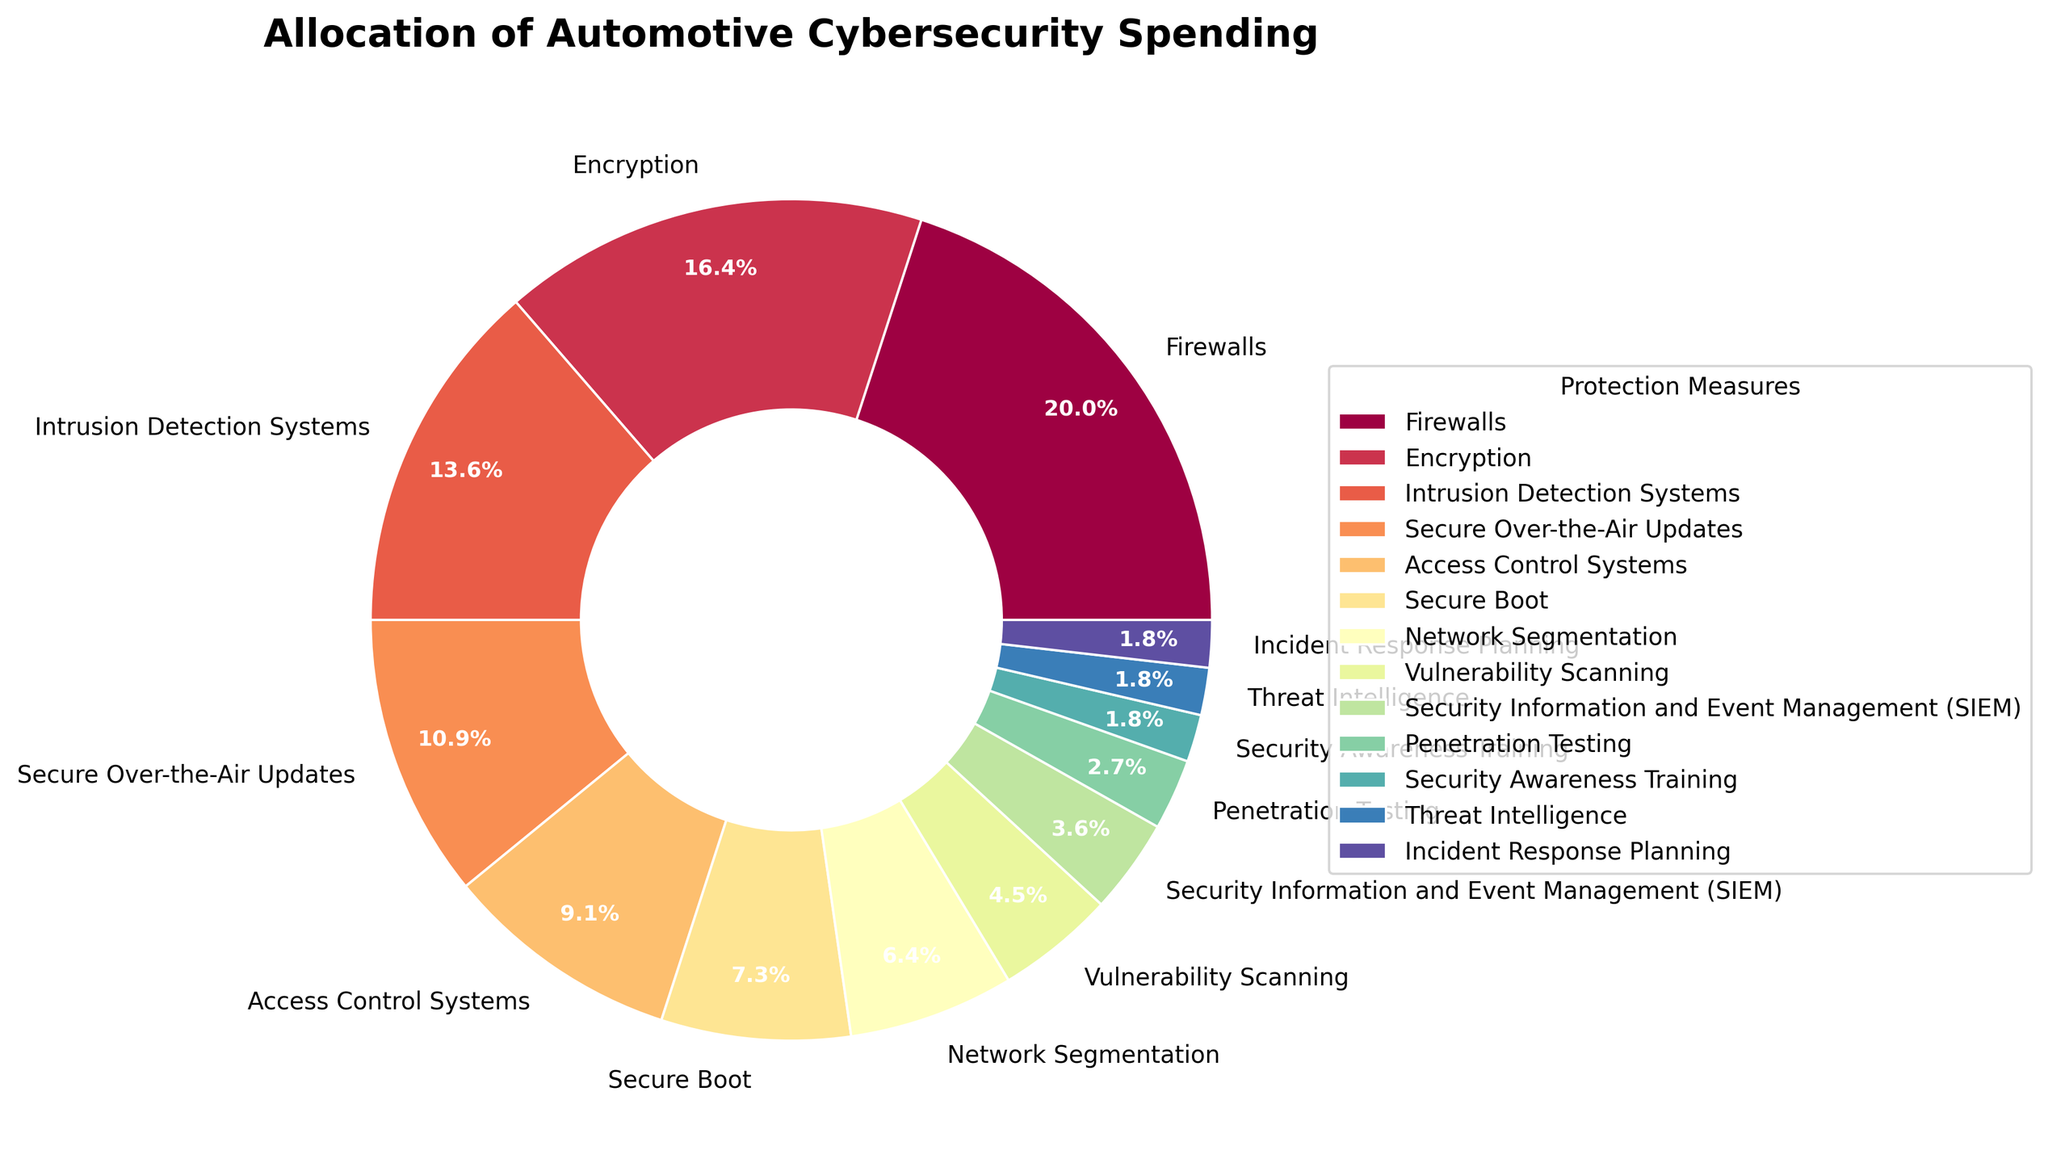How much more is spent on Firewalls compared to Encryption? The percentage allocated to Firewalls is 22%, and for Encryption, it is 18%. The difference can be calculated by subtracting the percentage for Encryption from Firewalls: 22% - 18% = 4%.
Answer: 4% Which two categories have the smallest allocations, and what are their combined percentages? The smallest allocations are Security Awareness Training, Threat Intelligence, and Incident Response Planning, each with 2% of the total spending. The combined percentage is calculated as 2% + 2% + 2% = 6%.
Answer: Security Awareness Training, Threat Intelligence, and Incident Response Planning, 6% What is the total percentage of spending allocated to Secure Boot and Network Segmentation combined? Secure Boot has a percentage of 8%, and Network Segmentation has a percentage of 7%. Adding these together gives 8% + 7% = 15%.
Answer: 15% Which category has the highest allocation, and by how much does it exceed the category with the second-highest allocation? Firewalls have the highest allocation at 22%. Encryption has the second-highest allocation at 18%. The difference is 22% - 18% = 4%.
Answer: Firewalls, 4% How does the percentage allocation for Access Control Systems compare to that for Intrusion Detection Systems? Access Control Systems have an allocation of 10%, whereas Intrusion Detection Systems have 15%. The difference is 15% - 10% = 5%. Therefore, Intrusion Detection Systems have 5% more allocation than Access Control Systems.
Answer: Intrusion Detection Systems, 5% Among the categories with single-digit percentage allocations, which one has the largest spend, and what is the percentage? Among the single-digit allocations, Secure Boot has the largest spend at 8%.
Answer: Secure Boot, 8% If we combine spending for Secure Over-the-Air Updates, Access Control Systems, and Network Segmentation, what is their total percentage? Secure Over-the-Air Updates have 12%, Access Control Systems have 10%, and Network Segmentation has 7%. Adding these together gives 12% + 10% + 7% = 29%.
Answer: 29% What visual attribute can you use to easily identify the category with the lowest allocation? In the pie chart, the category with the lowest allocation, 2%, will have the smallest wedge.
Answer: Smallest wedge How much percentage is spent on categories allocated 5% or less? The categories and their percentages are Vulnerability Scanning (5%), Security Information and Event Management (SIEM) (4%), Penetration Testing (3%), Security Awareness Training (2%), Threat Intelligence (2%), and Incident Response Planning (2%). Adding them together gives 5% + 4% + 3% + 2% + 2% + 2% = 18%.
Answer: 18% Which categories collectively constitute exactly one-third (33.3%) of the total spending? The categories and their percentages that collectively constitute one-third are Firewalls (22%) and Encryption (18%). Adding them together gives 22% + 18% = 40%, which exceeds one-third. Thus, consider Secure Over-the-Air Updates (12%), Access Control Systems (10%), Secure Boot (8%), and Network Segmentation (7%): 12% + 10% + 8% + 7% = 37%, still exceeding. Now consider Intrusion Detection Systems (15%) and Secure Over-the-Air Updates (12%), giving us 15% + 12% = 27%. Including the smallest categories can adjust the sum to 33.3%. Close to one-third would ultimately be Secure Over-the-Air Updates (12%), Access Control Systems (10%), and Intrusion Detection Systems (15%) summing up to 37%. Hence, None {refinement based on exact allocation matching}.
Answer: None 